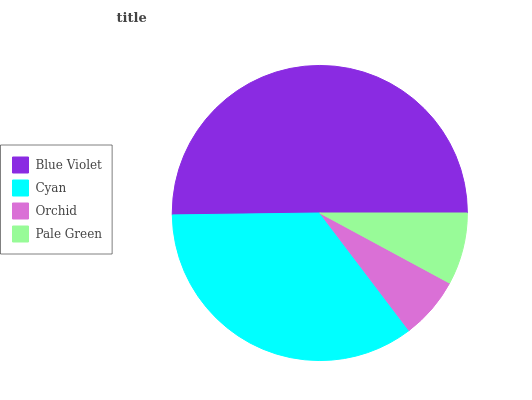Is Orchid the minimum?
Answer yes or no. Yes. Is Blue Violet the maximum?
Answer yes or no. Yes. Is Cyan the minimum?
Answer yes or no. No. Is Cyan the maximum?
Answer yes or no. No. Is Blue Violet greater than Cyan?
Answer yes or no. Yes. Is Cyan less than Blue Violet?
Answer yes or no. Yes. Is Cyan greater than Blue Violet?
Answer yes or no. No. Is Blue Violet less than Cyan?
Answer yes or no. No. Is Cyan the high median?
Answer yes or no. Yes. Is Pale Green the low median?
Answer yes or no. Yes. Is Blue Violet the high median?
Answer yes or no. No. Is Orchid the low median?
Answer yes or no. No. 